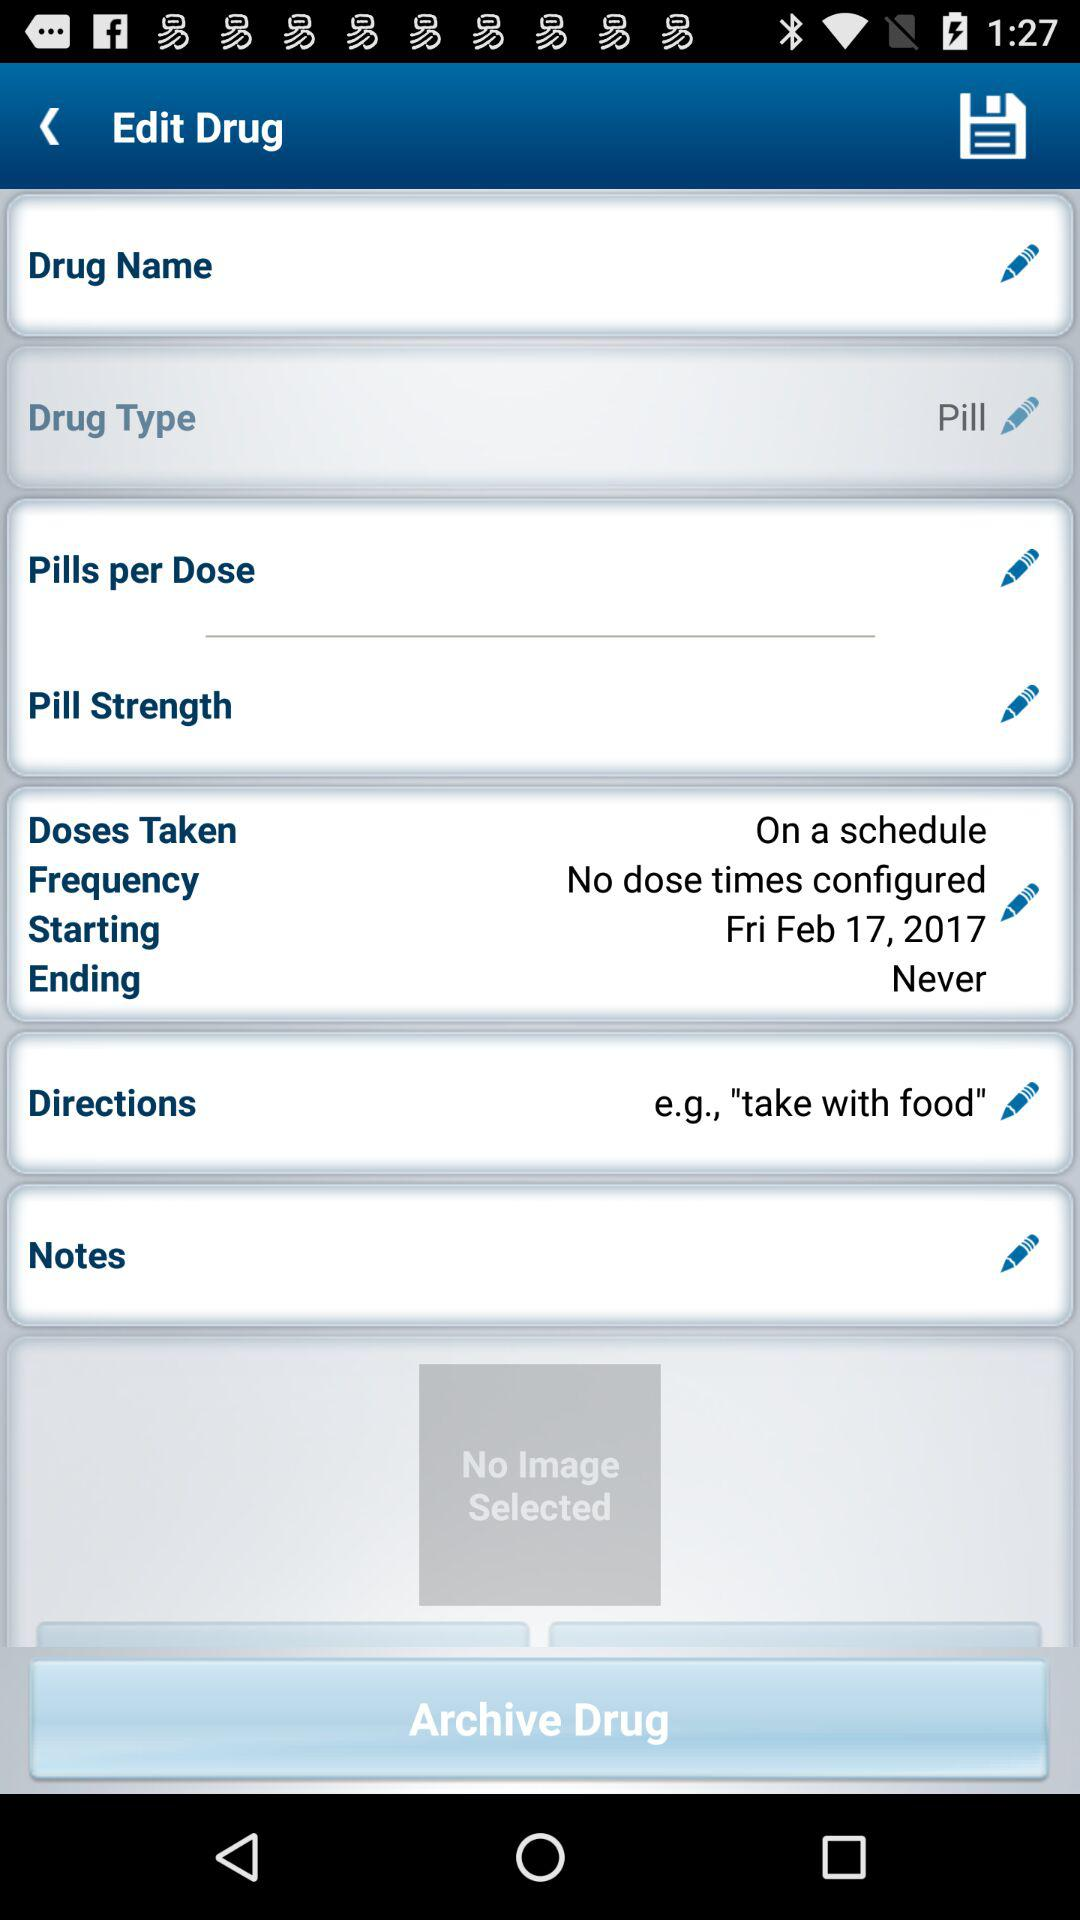What is the starting date for the dose? The starting date for the dose is Friday, February 17, 2017. 